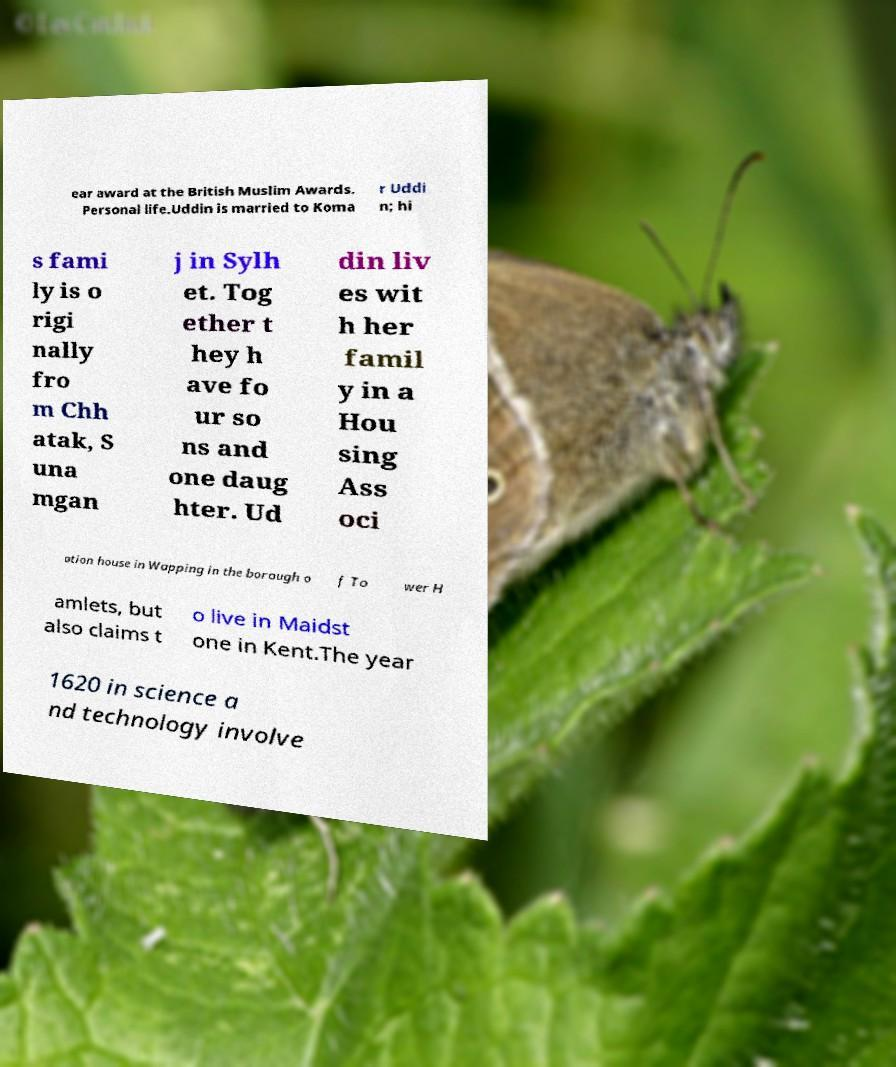Please identify and transcribe the text found in this image. ear award at the British Muslim Awards. Personal life.Uddin is married to Koma r Uddi n; hi s fami ly is o rigi nally fro m Chh atak, S una mgan j in Sylh et. Tog ether t hey h ave fo ur so ns and one daug hter. Ud din liv es wit h her famil y in a Hou sing Ass oci ation house in Wapping in the borough o f To wer H amlets, but also claims t o live in Maidst one in Kent.The year 1620 in science a nd technology involve 